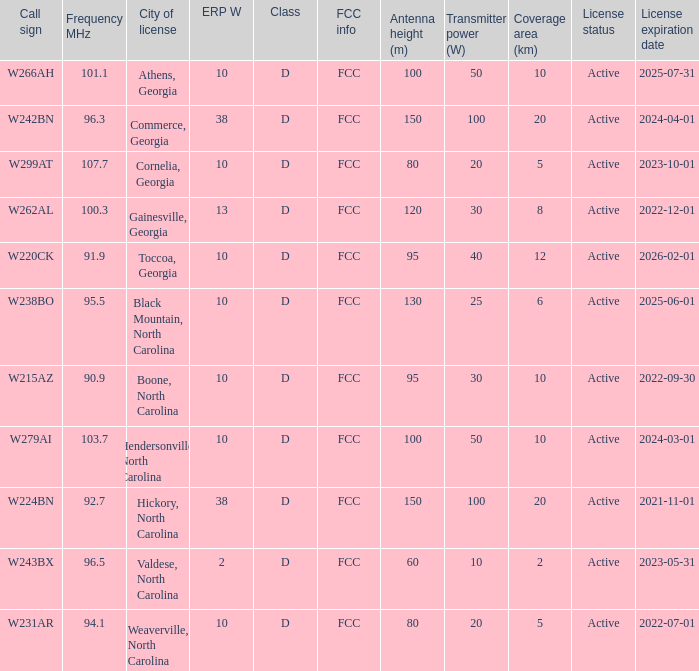What is the Frequency MHz for the station with a call sign of w224bn? 92.7. 